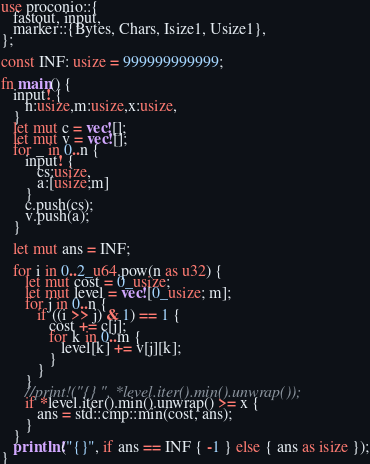<code> <loc_0><loc_0><loc_500><loc_500><_Rust_>use proconio::{
   fastout, input,
   marker::{Bytes, Chars, Isize1, Usize1},
};

const INF: usize = 999999999999;

fn main() {
   input! {
      n:usize,m:usize,x:usize,
   }
   let mut c = vec![];
   let mut v = vec![];
   for _ in 0..n {
      input! {
         cs:usize,
         a:[usize;m]
      }
      c.push(cs);
      v.push(a);
   }

   let mut ans = INF;

   for i in 0..2_u64.pow(n as u32) {
      let mut cost = 0_usize;
      let mut level = vec![0_usize; m];
      for j in 0..n {
         if ((i >> j) & 1) == 1 {
            cost += c[j];
            for k in 0..m {
               level[k] += v[j][k];
            }
         }
      }
      //print!("{} ", *level.iter().min().unwrap());
      if *level.iter().min().unwrap() >= x {
         ans = std::cmp::min(cost, ans);
      }
   }
   println!("{}", if ans == INF { -1 } else { ans as isize });
}
</code> 